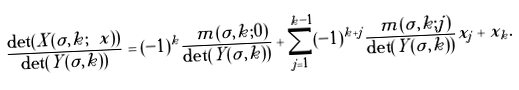Convert formula to latex. <formula><loc_0><loc_0><loc_500><loc_500>\frac { \det ( \tilde { X } ( \sigma , k ; \ x ) ) } { \det ( Y ( \sigma , k ) ) } = ( - 1 ) ^ { k } \frac { \ m ( \sigma , k ; 0 ) } { \det ( Y ( \sigma , k ) ) } + \sum _ { j = 1 } ^ { k - 1 } ( - 1 ) ^ { k + j } \frac { \ m ( \sigma , k ; j ) } { \det ( Y ( \sigma , k ) ) } x _ { j } + x _ { k } .</formula> 